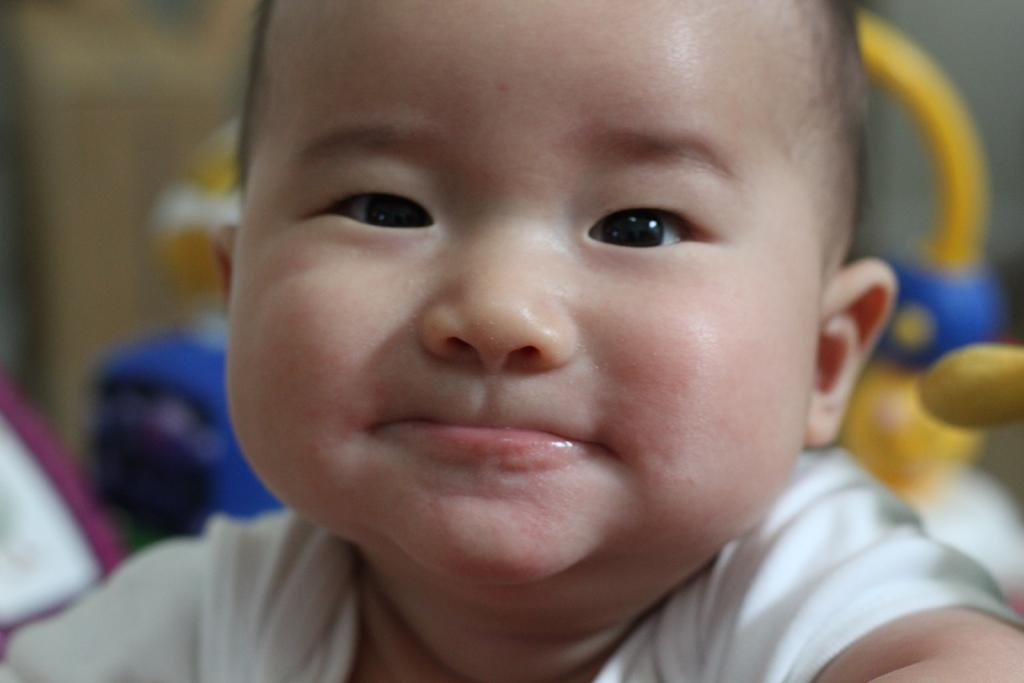What is the main subject of the image? There is a baby in the image. What is the baby doing in the image? The baby is smiling. What else can be seen in the image besides the baby? There are toys in the image. Can you describe the background of the image? The background of the image appears blurry. What type of orange is being used as a spoon in the image? There is no orange or spoon present in the image. What discovery was made by the baby in the image? There is no indication of a discovery made by the baby in the image. 